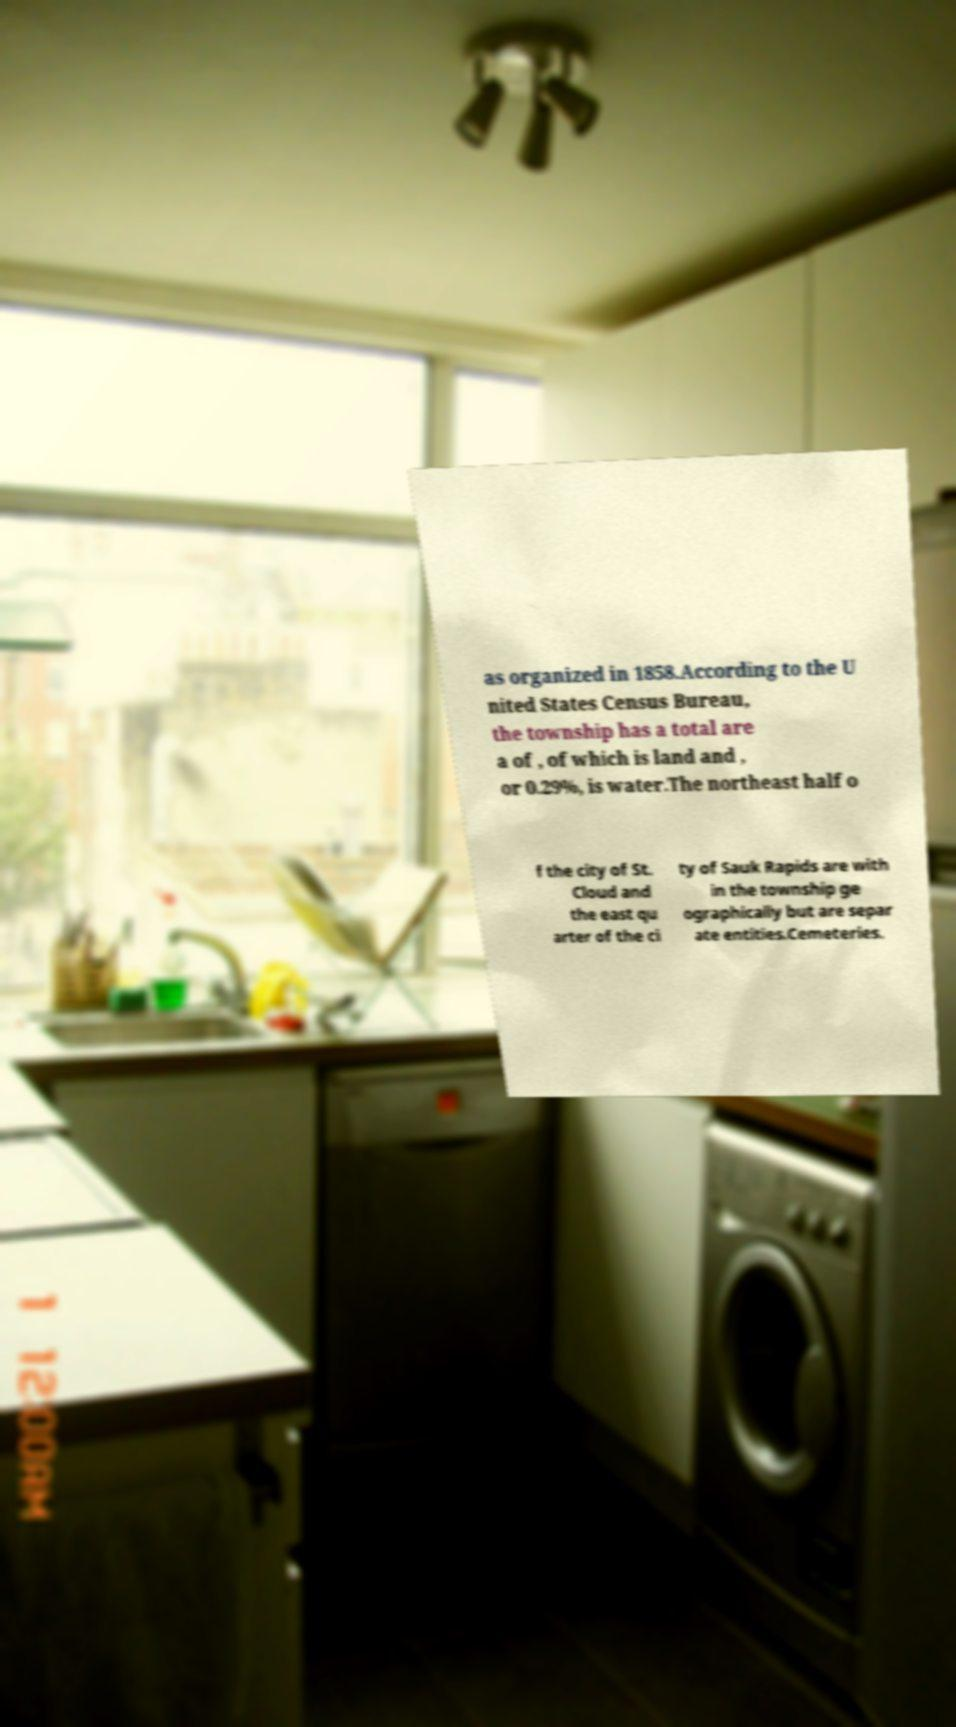Please read and relay the text visible in this image. What does it say? as organized in 1858.According to the U nited States Census Bureau, the township has a total are a of , of which is land and , or 0.29%, is water.The northeast half o f the city of St. Cloud and the east qu arter of the ci ty of Sauk Rapids are with in the township ge ographically but are separ ate entities.Cemeteries. 